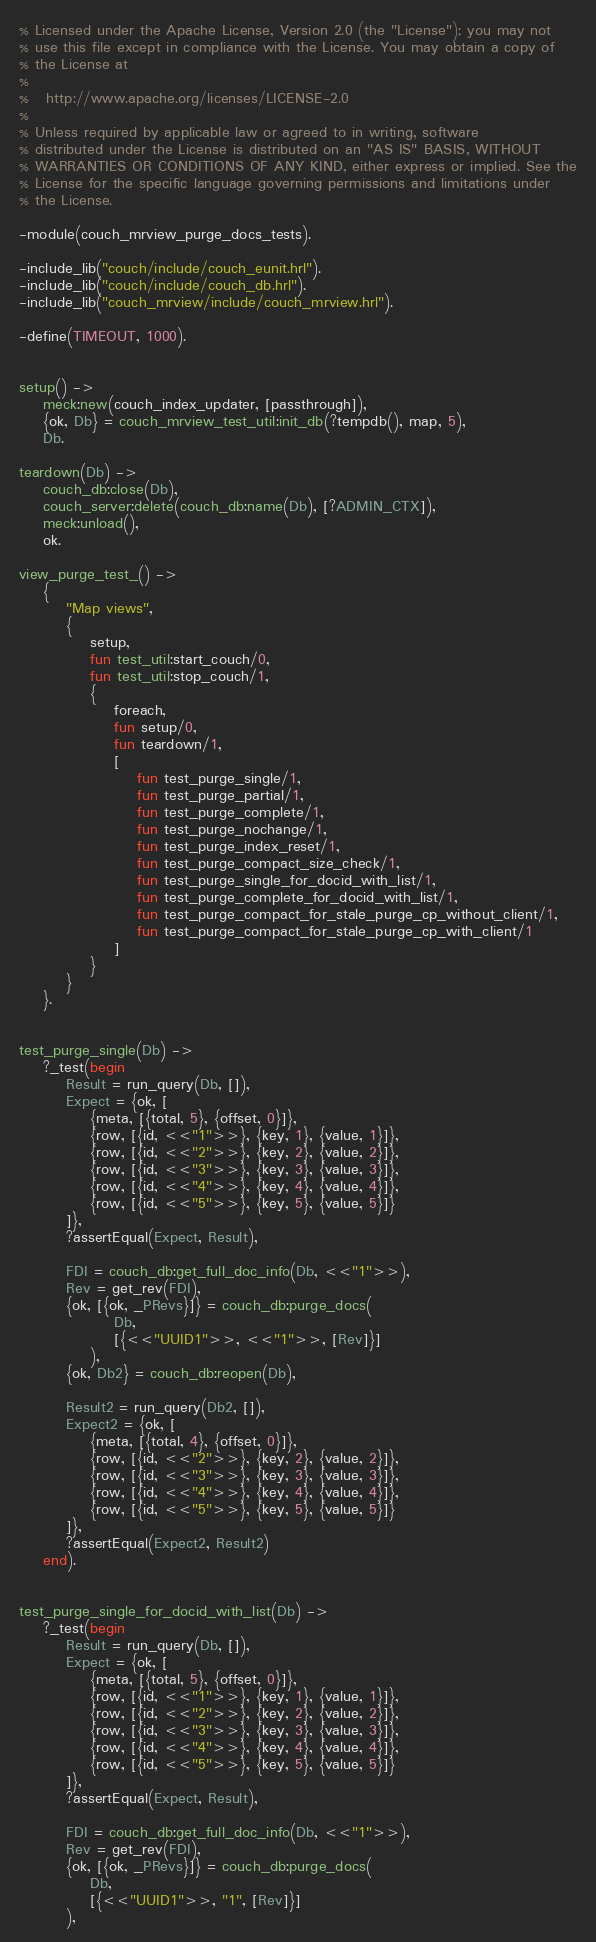<code> <loc_0><loc_0><loc_500><loc_500><_Erlang_>% Licensed under the Apache License, Version 2.0 (the "License"); you may not
% use this file except in compliance with the License. You may obtain a copy of
% the License at
%
%   http://www.apache.org/licenses/LICENSE-2.0
%
% Unless required by applicable law or agreed to in writing, software
% distributed under the License is distributed on an "AS IS" BASIS, WITHOUT
% WARRANTIES OR CONDITIONS OF ANY KIND, either express or implied. See the
% License for the specific language governing permissions and limitations under
% the License.

-module(couch_mrview_purge_docs_tests).

-include_lib("couch/include/couch_eunit.hrl").
-include_lib("couch/include/couch_db.hrl").
-include_lib("couch_mrview/include/couch_mrview.hrl").

-define(TIMEOUT, 1000).


setup() ->
    meck:new(couch_index_updater, [passthrough]),
    {ok, Db} = couch_mrview_test_util:init_db(?tempdb(), map, 5),
    Db.

teardown(Db) ->
    couch_db:close(Db),
    couch_server:delete(couch_db:name(Db), [?ADMIN_CTX]),
    meck:unload(),
    ok.

view_purge_test_() ->
    {
        "Map views",
        {
            setup,
            fun test_util:start_couch/0,
            fun test_util:stop_couch/1,
            {
                foreach,
                fun setup/0,
                fun teardown/1,
                [
                    fun test_purge_single/1,
                    fun test_purge_partial/1,
                    fun test_purge_complete/1,
                    fun test_purge_nochange/1,
                    fun test_purge_index_reset/1,
                    fun test_purge_compact_size_check/1,
                    fun test_purge_single_for_docid_with_list/1,
                    fun test_purge_complete_for_docid_with_list/1,
                    fun test_purge_compact_for_stale_purge_cp_without_client/1,
                    fun test_purge_compact_for_stale_purge_cp_with_client/1
                ]
            }
        }
    }.


test_purge_single(Db) ->
    ?_test(begin
        Result = run_query(Db, []),
        Expect = {ok, [
            {meta, [{total, 5}, {offset, 0}]},
            {row, [{id, <<"1">>}, {key, 1}, {value, 1}]},
            {row, [{id, <<"2">>}, {key, 2}, {value, 2}]},
            {row, [{id, <<"3">>}, {key, 3}, {value, 3}]},
            {row, [{id, <<"4">>}, {key, 4}, {value, 4}]},
            {row, [{id, <<"5">>}, {key, 5}, {value, 5}]}
        ]},
        ?assertEqual(Expect, Result),

        FDI = couch_db:get_full_doc_info(Db, <<"1">>),
        Rev = get_rev(FDI),
        {ok, [{ok, _PRevs}]} = couch_db:purge_docs(
                Db,
                [{<<"UUID1">>, <<"1">>, [Rev]}]
            ),
        {ok, Db2} = couch_db:reopen(Db),

        Result2 = run_query(Db2, []),
        Expect2 = {ok, [
            {meta, [{total, 4}, {offset, 0}]},
            {row, [{id, <<"2">>}, {key, 2}, {value, 2}]},
            {row, [{id, <<"3">>}, {key, 3}, {value, 3}]},
            {row, [{id, <<"4">>}, {key, 4}, {value, 4}]},
            {row, [{id, <<"5">>}, {key, 5}, {value, 5}]}
        ]},
        ?assertEqual(Expect2, Result2)
    end).


test_purge_single_for_docid_with_list(Db) ->
    ?_test(begin
        Result = run_query(Db, []),
        Expect = {ok, [
            {meta, [{total, 5}, {offset, 0}]},
            {row, [{id, <<"1">>}, {key, 1}, {value, 1}]},
            {row, [{id, <<"2">>}, {key, 2}, {value, 2}]},
            {row, [{id, <<"3">>}, {key, 3}, {value, 3}]},
            {row, [{id, <<"4">>}, {key, 4}, {value, 4}]},
            {row, [{id, <<"5">>}, {key, 5}, {value, 5}]}
        ]},
        ?assertEqual(Expect, Result),

        FDI = couch_db:get_full_doc_info(Db, <<"1">>),
        Rev = get_rev(FDI),
        {ok, [{ok, _PRevs}]} = couch_db:purge_docs(
            Db,
            [{<<"UUID1">>, "1", [Rev]}]
        ),</code> 